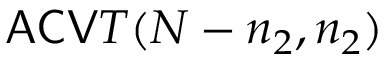Convert formula to latex. <formula><loc_0><loc_0><loc_500><loc_500>A C V T ( N - n _ { 2 } , n _ { 2 } )</formula> 